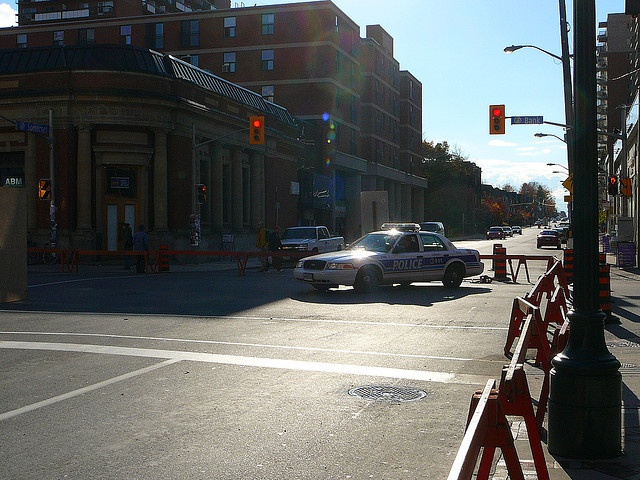Describe the objects in this image and their specific colors. I can see car in lightblue, black, gray, white, and blue tones, truck in lightblue, black, gray, and blue tones, people in black and lightblue tones, people in lightblue and black tones, and traffic light in lightblue, maroon, black, and brown tones in this image. 